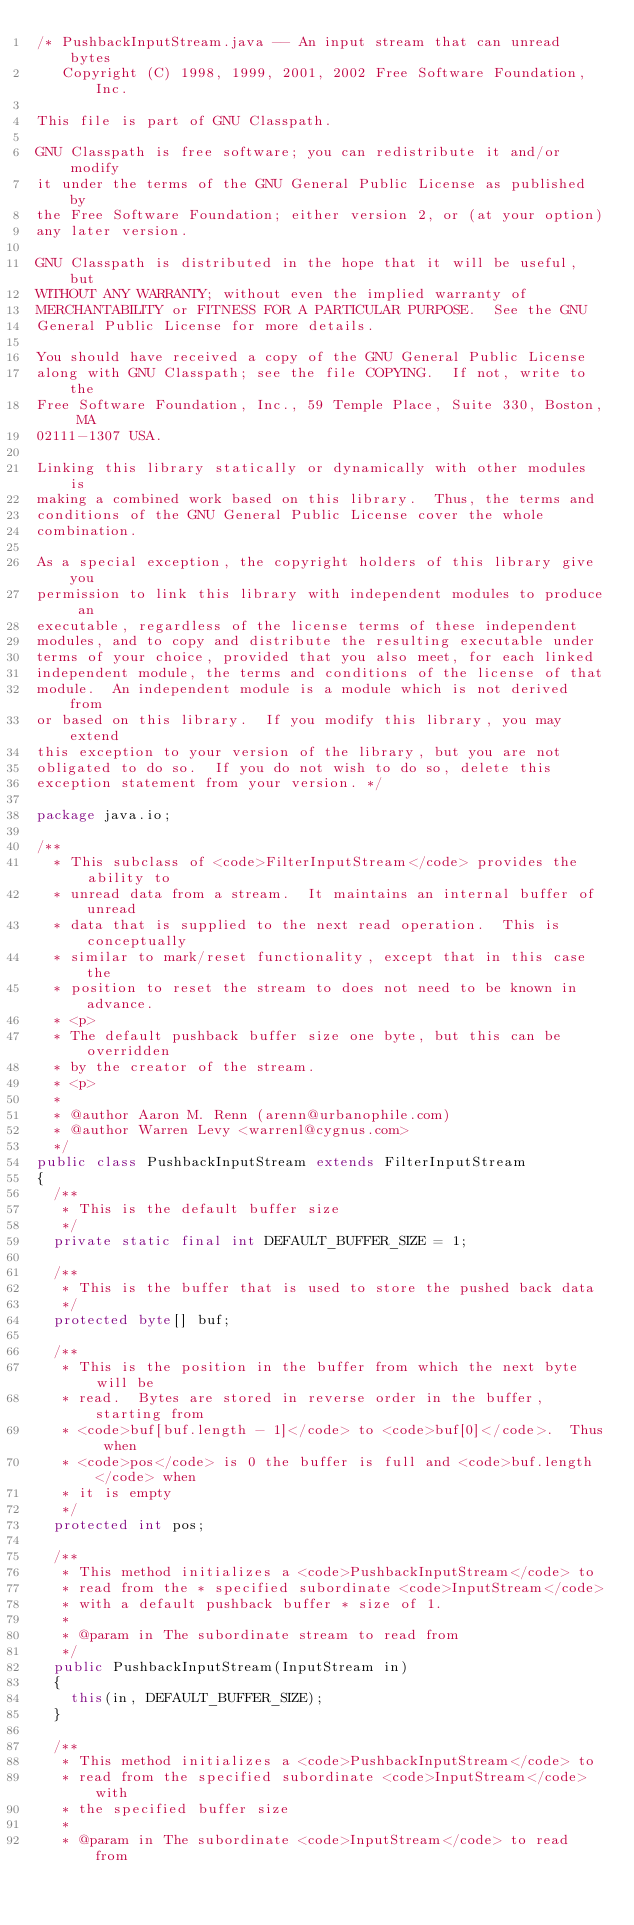Convert code to text. <code><loc_0><loc_0><loc_500><loc_500><_Java_>/* PushbackInputStream.java -- An input stream that can unread bytes
   Copyright (C) 1998, 1999, 2001, 2002 Free Software Foundation, Inc.

This file is part of GNU Classpath.

GNU Classpath is free software; you can redistribute it and/or modify
it under the terms of the GNU General Public License as published by
the Free Software Foundation; either version 2, or (at your option)
any later version.
 
GNU Classpath is distributed in the hope that it will be useful, but
WITHOUT ANY WARRANTY; without even the implied warranty of
MERCHANTABILITY or FITNESS FOR A PARTICULAR PURPOSE.  See the GNU
General Public License for more details.

You should have received a copy of the GNU General Public License
along with GNU Classpath; see the file COPYING.  If not, write to the
Free Software Foundation, Inc., 59 Temple Place, Suite 330, Boston, MA
02111-1307 USA.

Linking this library statically or dynamically with other modules is
making a combined work based on this library.  Thus, the terms and
conditions of the GNU General Public License cover the whole
combination.

As a special exception, the copyright holders of this library give you
permission to link this library with independent modules to produce an
executable, regardless of the license terms of these independent
modules, and to copy and distribute the resulting executable under
terms of your choice, provided that you also meet, for each linked
independent module, the terms and conditions of the license of that
module.  An independent module is a module which is not derived from
or based on this library.  If you modify this library, you may extend
this exception to your version of the library, but you are not
obligated to do so.  If you do not wish to do so, delete this
exception statement from your version. */

package java.io;

/**
  * This subclass of <code>FilterInputStream</code> provides the ability to 
  * unread data from a stream.  It maintains an internal buffer of unread
  * data that is supplied to the next read operation.  This is conceptually
  * similar to mark/reset functionality, except that in this case the 
  * position to reset the stream to does not need to be known in advance.
  * <p>
  * The default pushback buffer size one byte, but this can be overridden
  * by the creator of the stream.
  * <p>
  *
  * @author Aaron M. Renn (arenn@urbanophile.com)
  * @author Warren Levy <warrenl@cygnus.com>
  */
public class PushbackInputStream extends FilterInputStream
{
  /**
   * This is the default buffer size
   */
  private static final int DEFAULT_BUFFER_SIZE = 1;

  /**
   * This is the buffer that is used to store the pushed back data
   */
  protected byte[] buf;

  /**
   * This is the position in the buffer from which the next byte will be
   * read.  Bytes are stored in reverse order in the buffer, starting from
   * <code>buf[buf.length - 1]</code> to <code>buf[0]</code>.  Thus when 
   * <code>pos</code> is 0 the buffer is full and <code>buf.length</code> when 
   * it is empty
   */
  protected int pos;

  /**
   * This method initializes a <code>PushbackInputStream</code> to
   * read from the * specified subordinate <code>InputStream</code>
   * with a default pushback buffer * size of 1.
   *
   * @param in The subordinate stream to read from
   */
  public PushbackInputStream(InputStream in)
  {
    this(in, DEFAULT_BUFFER_SIZE);
  }

  /**
   * This method initializes a <code>PushbackInputStream</code> to
   * read from the specified subordinate <code>InputStream</code> with
   * the specified buffer size
   *
   * @param in The subordinate <code>InputStream</code> to read from</code> 